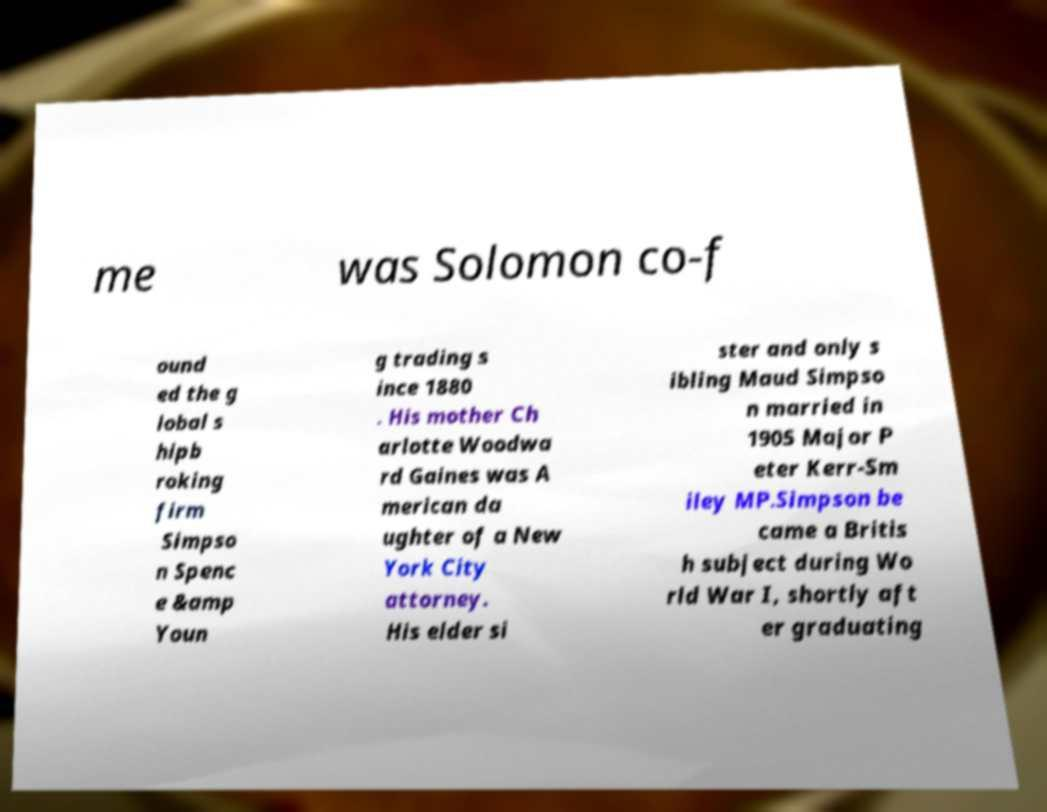Could you assist in decoding the text presented in this image and type it out clearly? me was Solomon co-f ound ed the g lobal s hipb roking firm Simpso n Spenc e &amp Youn g trading s ince 1880 . His mother Ch arlotte Woodwa rd Gaines was A merican da ughter of a New York City attorney. His elder si ster and only s ibling Maud Simpso n married in 1905 Major P eter Kerr-Sm iley MP.Simpson be came a Britis h subject during Wo rld War I, shortly aft er graduating 